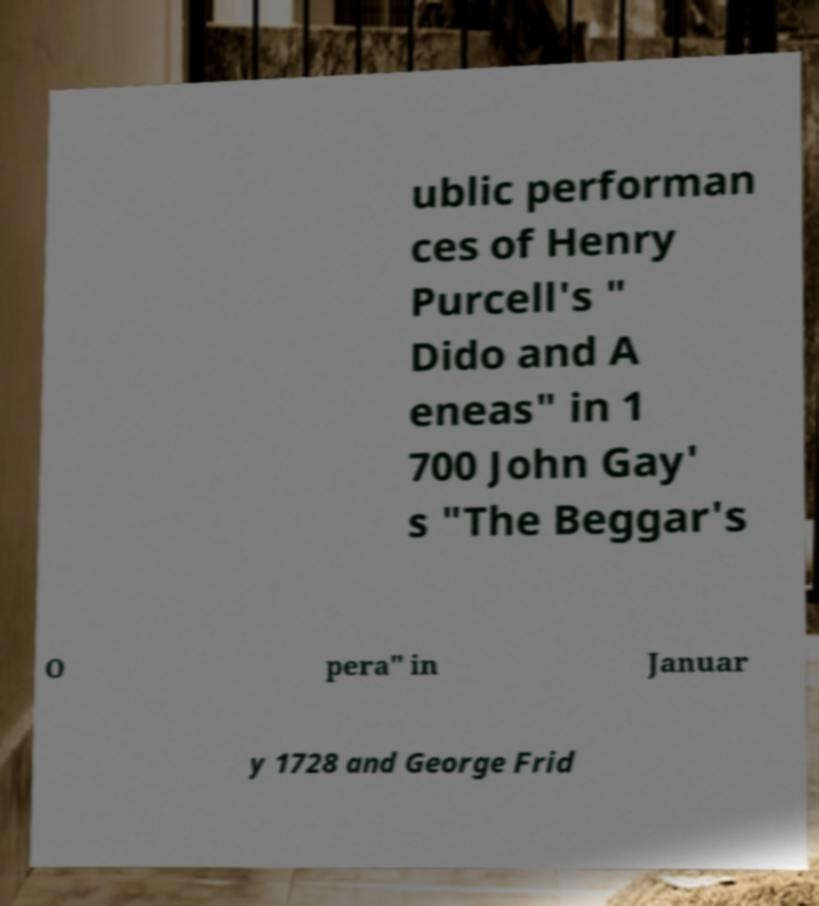Can you read and provide the text displayed in the image?This photo seems to have some interesting text. Can you extract and type it out for me? ublic performan ces of Henry Purcell's " Dido and A eneas" in 1 700 John Gay' s "The Beggar's O pera" in Januar y 1728 and George Frid 